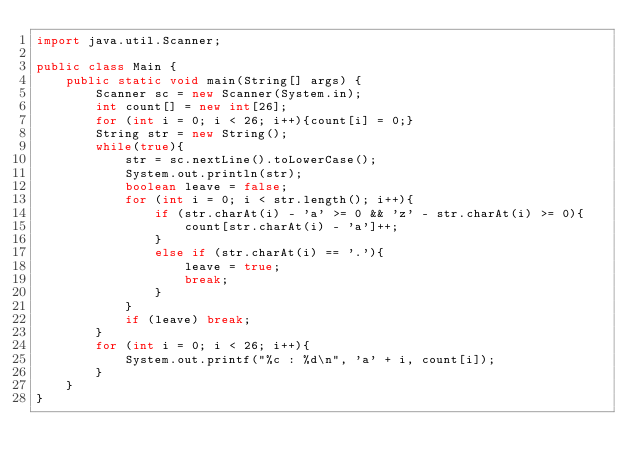<code> <loc_0><loc_0><loc_500><loc_500><_Java_>import java.util.Scanner;

public class Main {
    public static void main(String[] args) {
        Scanner sc = new Scanner(System.in);
        int count[] = new int[26];
        for (int i = 0; i < 26; i++){count[i] = 0;}
        String str = new String();
        while(true){
            str = sc.nextLine().toLowerCase();
            System.out.println(str);
            boolean leave = false;
            for (int i = 0; i < str.length(); i++){
                if (str.charAt(i) - 'a' >= 0 && 'z' - str.charAt(i) >= 0){
                    count[str.charAt(i) - 'a']++;
                }
                else if (str.charAt(i) == '.'){
                    leave = true;
                    break;
                }
            }
            if (leave) break;
        }
        for (int i = 0; i < 26; i++){
            System.out.printf("%c : %d\n", 'a' + i, count[i]);
        }
    }
}</code> 